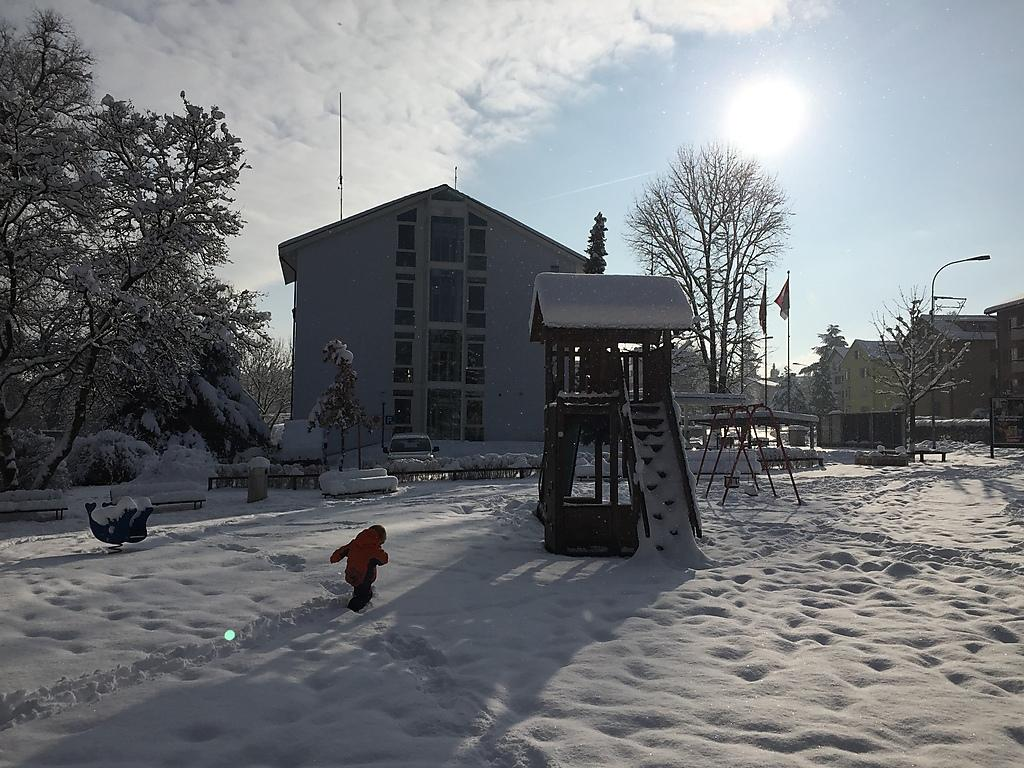What is the main subject in the middle of the picture? There is a building in the middle of the picture. What is the condition of the ground in the image? There is snow on the ground. What can be seen in the background of the image? There are trees in the background of the image. What is visible in the sky in the image? There are clouds in the sky. How many stockings are hanging from the building in the image? There are no stockings hanging from the building in the image. What type of spoon can be seen in the hands of the dolls in the image? There are no dolls or spoons present in the image. 